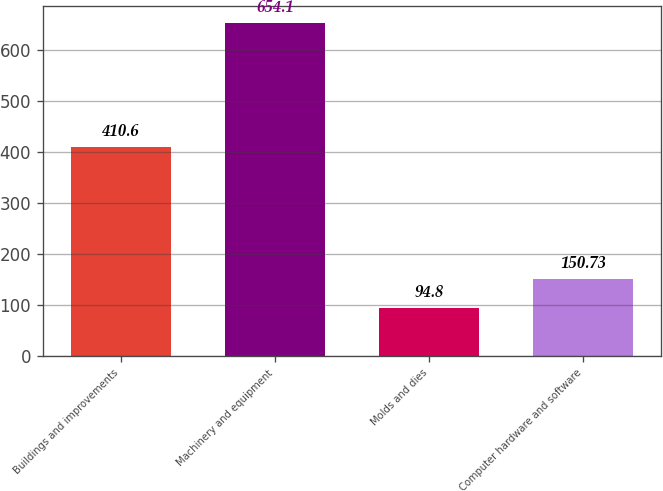Convert chart. <chart><loc_0><loc_0><loc_500><loc_500><bar_chart><fcel>Buildings and improvements<fcel>Machinery and equipment<fcel>Molds and dies<fcel>Computer hardware and software<nl><fcel>410.6<fcel>654.1<fcel>94.8<fcel>150.73<nl></chart> 